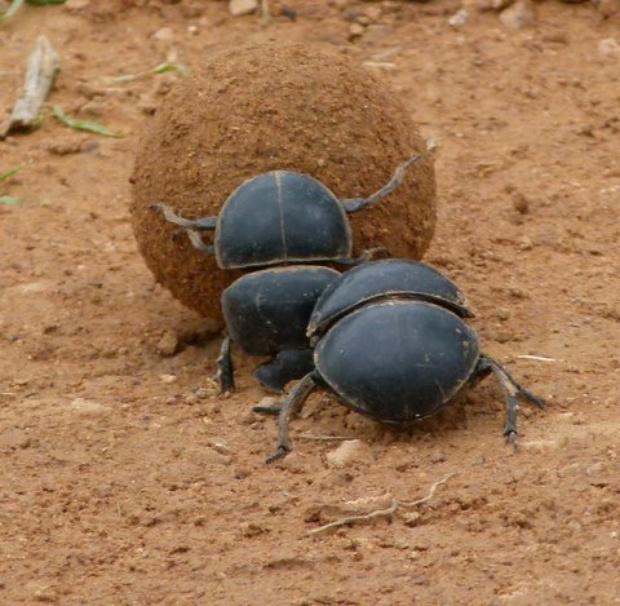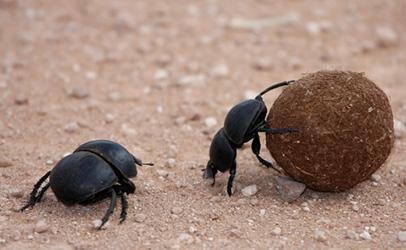The first image is the image on the left, the second image is the image on the right. For the images shown, is this caption "The left image contains two beetles." true? Answer yes or no. Yes. 